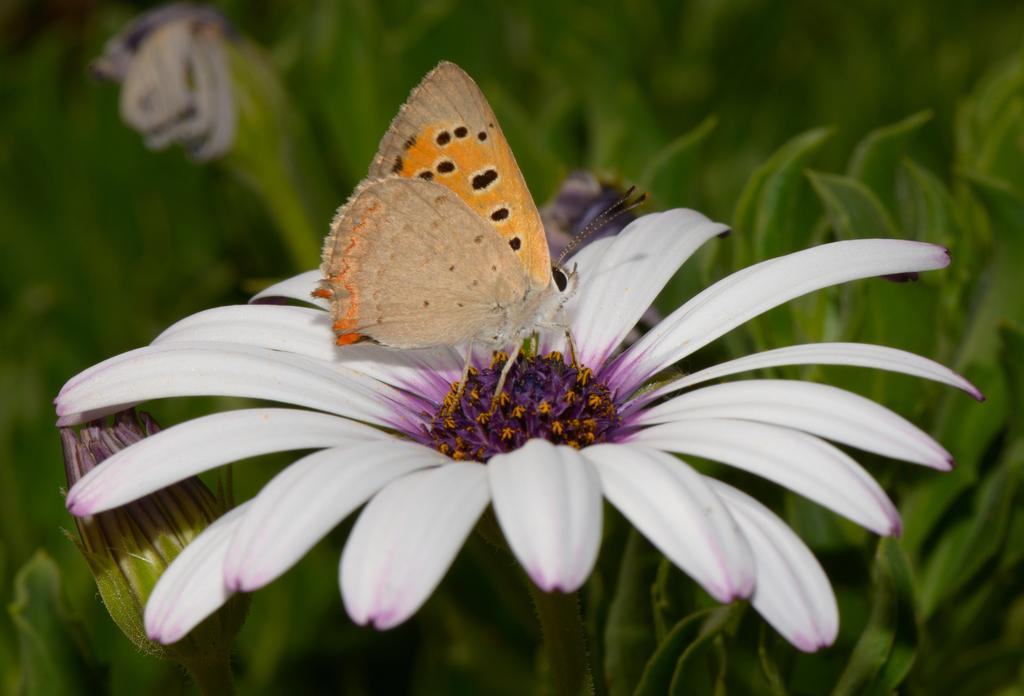What types of flora are present in the image? There are flowers and plants in the image. Can you describe any specific details about the flowers? The flower has white and purple colors. What insect can be seen in the image? There is a butterfly on a flower in the image. What type of acoustics can be heard from the flowers in the image? There is no sound or acoustics associated with the flowers in the image. Is there a hat visible on any of the plants in the image? There is no hat present in the image. 